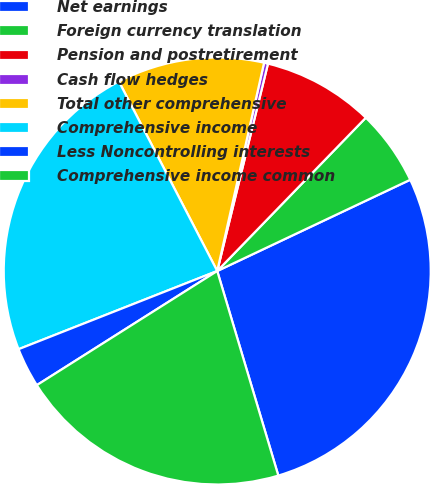<chart> <loc_0><loc_0><loc_500><loc_500><pie_chart><fcel>Net earnings<fcel>Foreign currency translation<fcel>Pension and postretirement<fcel>Cash flow hedges<fcel>Total other comprehensive<fcel>Comprehensive income<fcel>Less Noncontrolling interests<fcel>Comprehensive income common<nl><fcel>27.41%<fcel>5.72%<fcel>8.43%<fcel>0.3%<fcel>11.14%<fcel>23.35%<fcel>3.01%<fcel>20.64%<nl></chart> 